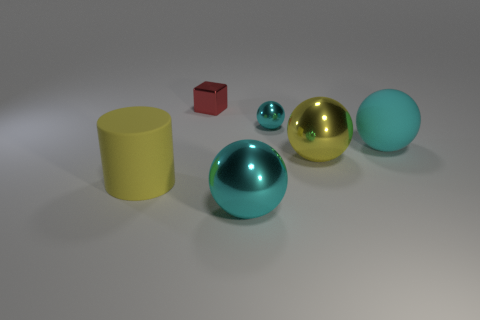How many yellow metal things are to the right of the tiny thing that is in front of the small thing that is left of the tiny cyan ball?
Provide a short and direct response. 1. There is a tiny thing that is to the right of the block; is its color the same as the matte object in front of the big cyan matte ball?
Offer a very short reply. No. The sphere that is both behind the big yellow metal thing and to the left of the big cyan matte object is what color?
Keep it short and to the point. Cyan. How many cylinders have the same size as the cyan rubber sphere?
Provide a succinct answer. 1. The large cyan thing right of the tiny object on the right side of the tiny red object is what shape?
Provide a short and direct response. Sphere. There is a yellow thing that is to the left of the large cyan object that is on the left side of the matte sphere that is behind the large yellow shiny thing; what is its shape?
Give a very brief answer. Cylinder. How many other cyan things are the same shape as the big cyan metal object?
Ensure brevity in your answer.  2. There is a small metal thing that is in front of the tiny red metal thing; what number of big objects are in front of it?
Your answer should be compact. 4. What number of rubber things are big yellow objects or red cubes?
Make the answer very short. 1. Are there any yellow cylinders made of the same material as the tiny cyan object?
Your answer should be compact. No. 